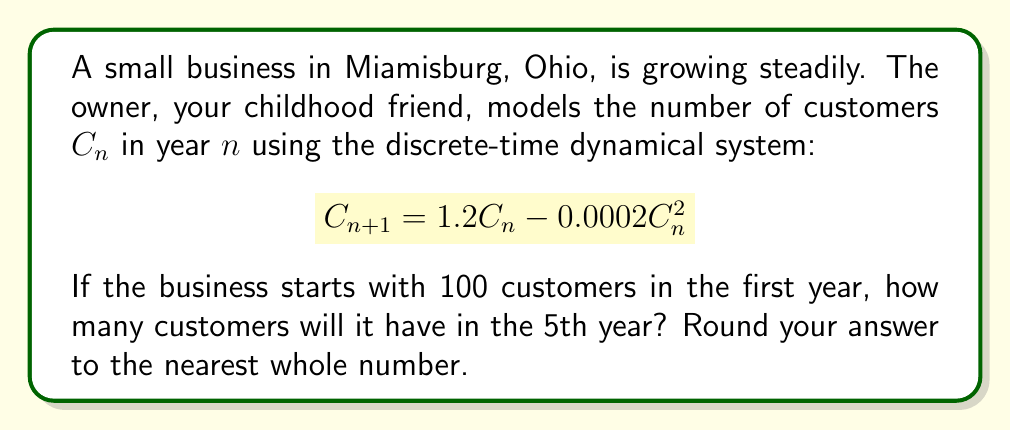Teach me how to tackle this problem. Let's solve this step-by-step:

1) We start with $C_1 = 100$ customers in the first year.

2) We'll use the given equation to calculate the number of customers for each subsequent year:

   $C_{n+1} = 1.2C_n - 0.0002C_n^2$

3) For year 2:
   $C_2 = 1.2(100) - 0.0002(100)^2 = 120 - 2 = 118$

4) For year 3:
   $C_3 = 1.2(118) - 0.0002(118)^2 = 141.6 - 2.7848 = 138.8152$

5) For year 4:
   $C_4 = 1.2(138.8152) - 0.0002(138.8152)^2 = 166.57824 - 3.85295 = 162.72529$

6) For year 5:
   $C_5 = 1.2(162.72529) - 0.0002(162.72529)^2 = 195.270348 - 5.29555 = 189.974798$

7) Rounding to the nearest whole number: 190
Answer: 190 customers 